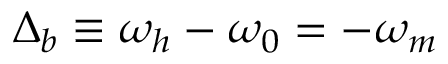<formula> <loc_0><loc_0><loc_500><loc_500>\Delta _ { b } \equiv \omega _ { h } - \omega _ { 0 } = - \omega _ { m }</formula> 